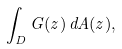Convert formula to latex. <formula><loc_0><loc_0><loc_500><loc_500>\int _ { D } G ( z ) \, d A ( z ) ,</formula> 